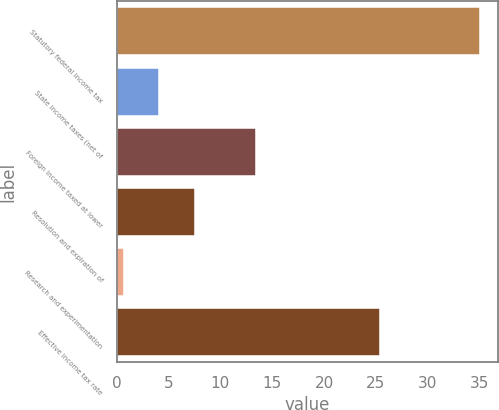<chart> <loc_0><loc_0><loc_500><loc_500><bar_chart><fcel>Statutory federal income tax<fcel>State income taxes (net of<fcel>Foreign income taxed at lower<fcel>Resolution and expiration of<fcel>Research and experimentation<fcel>Effective income tax rate<nl><fcel>35<fcel>4.13<fcel>13.4<fcel>7.56<fcel>0.7<fcel>25.4<nl></chart> 